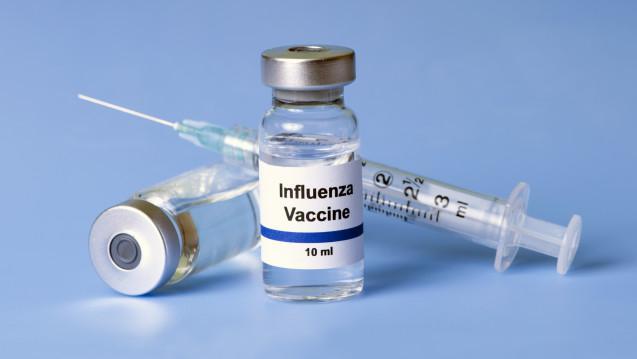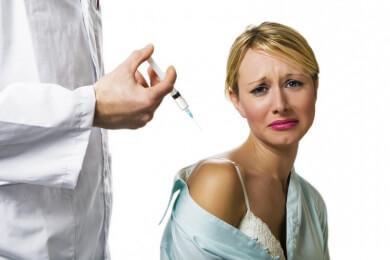The first image is the image on the left, the second image is the image on the right. For the images shown, is this caption "There are exactly two syringes." true? Answer yes or no. Yes. The first image is the image on the left, the second image is the image on the right. Examine the images to the left and right. Is the description "There are no more than 2 syringes." accurate? Answer yes or no. Yes. 